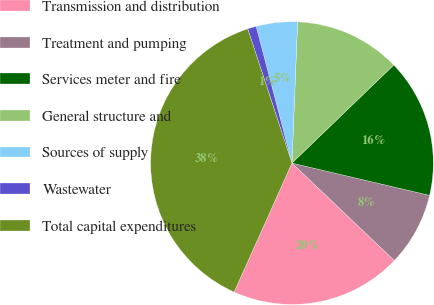Convert chart. <chart><loc_0><loc_0><loc_500><loc_500><pie_chart><fcel>Transmission and distribution<fcel>Treatment and pumping<fcel>Services meter and fire<fcel>General structure and<fcel>Sources of supply<fcel>Wastewater<fcel>Total capital expenditures<nl><fcel>19.6%<fcel>8.44%<fcel>15.88%<fcel>12.16%<fcel>4.71%<fcel>0.99%<fcel>38.22%<nl></chart> 